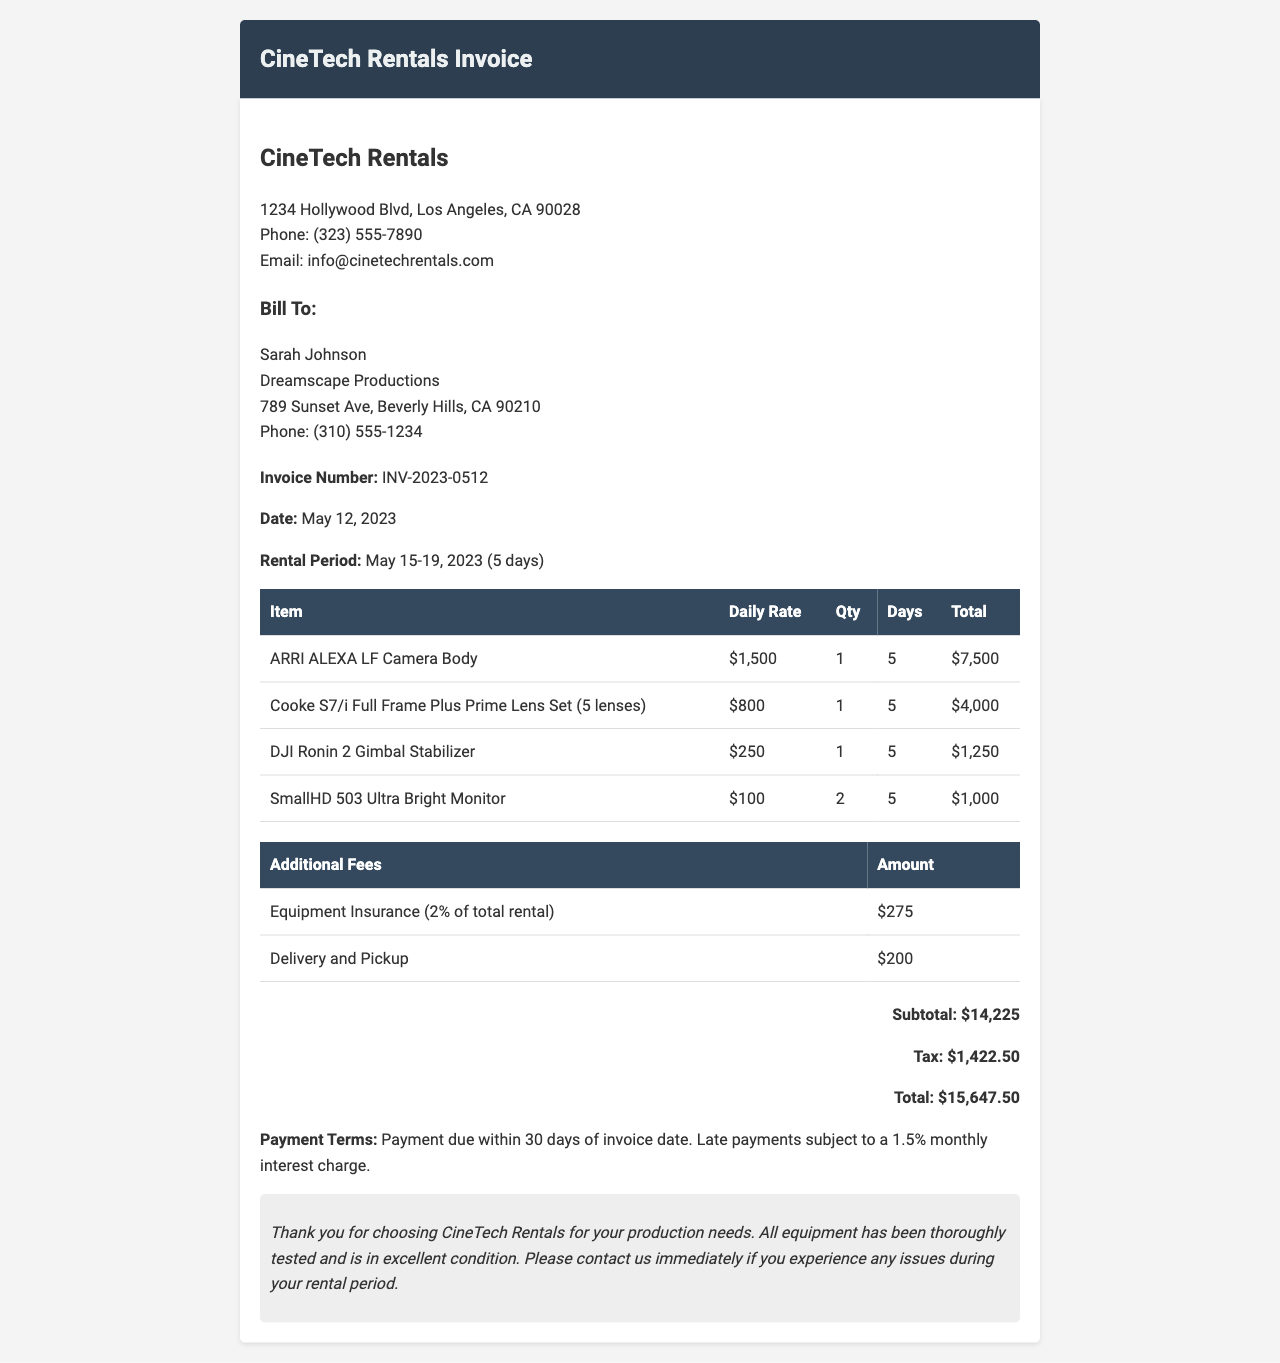What is the invoice number? The invoice number is a unique identifier for the billing document, listed in the invoice details section.
Answer: INV-2023-0512 What is the rental period? The rental period indicates the specific dates when the equipment is to be rented, noted in the invoice details.
Answer: May 15-19, 2023 How much does the ARRI ALEXA LF Camera Body cost per day? This is the daily rental rate for the camera body, mentioned in the item details.
Answer: $1,500 What is the subtotal amount? The subtotal represents the sum of all equipment and additional fees before tax, provided in the totals section.
Answer: $14,225 How much is the equipment insurance fee? This fee is calculated as a percentage of the total rental cost and is specified in the additional fees table.
Answer: $275 What is the total amount due? The total amount is the final charge including subtotal, tax, and additional fees, found in the totals section.
Answer: $15,647.50 Who is the invoice billed to? This refers to the name of the client as listed in the client info section of the invoice.
Answer: Sarah Johnson What additional service is charged $200? This is an additional fee associated with the rental service, detailed in the additional fees table.
Answer: Delivery and Pickup What is the payment term indicated in the document? The payment term describes the conditions under which payment is expected, stated at the end of the invoice.
Answer: Payment due within 30 days of invoice date 